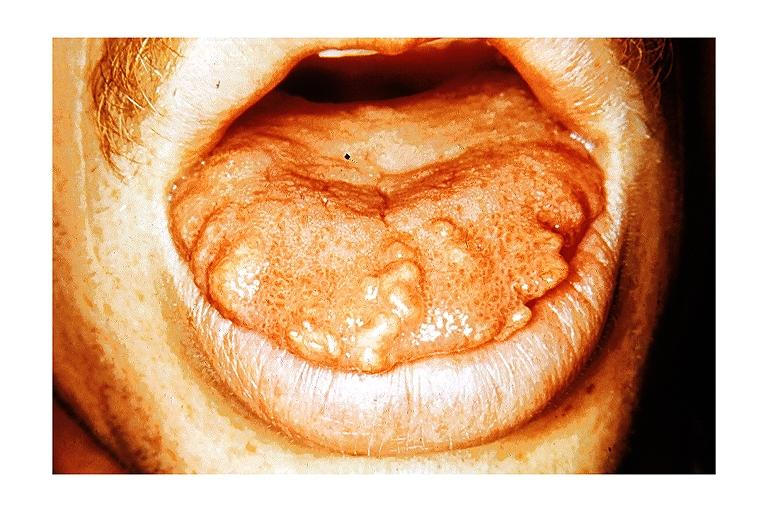does this image show multiple endocrine neoplasia type iib-macroglossia?
Answer the question using a single word or phrase. Yes 